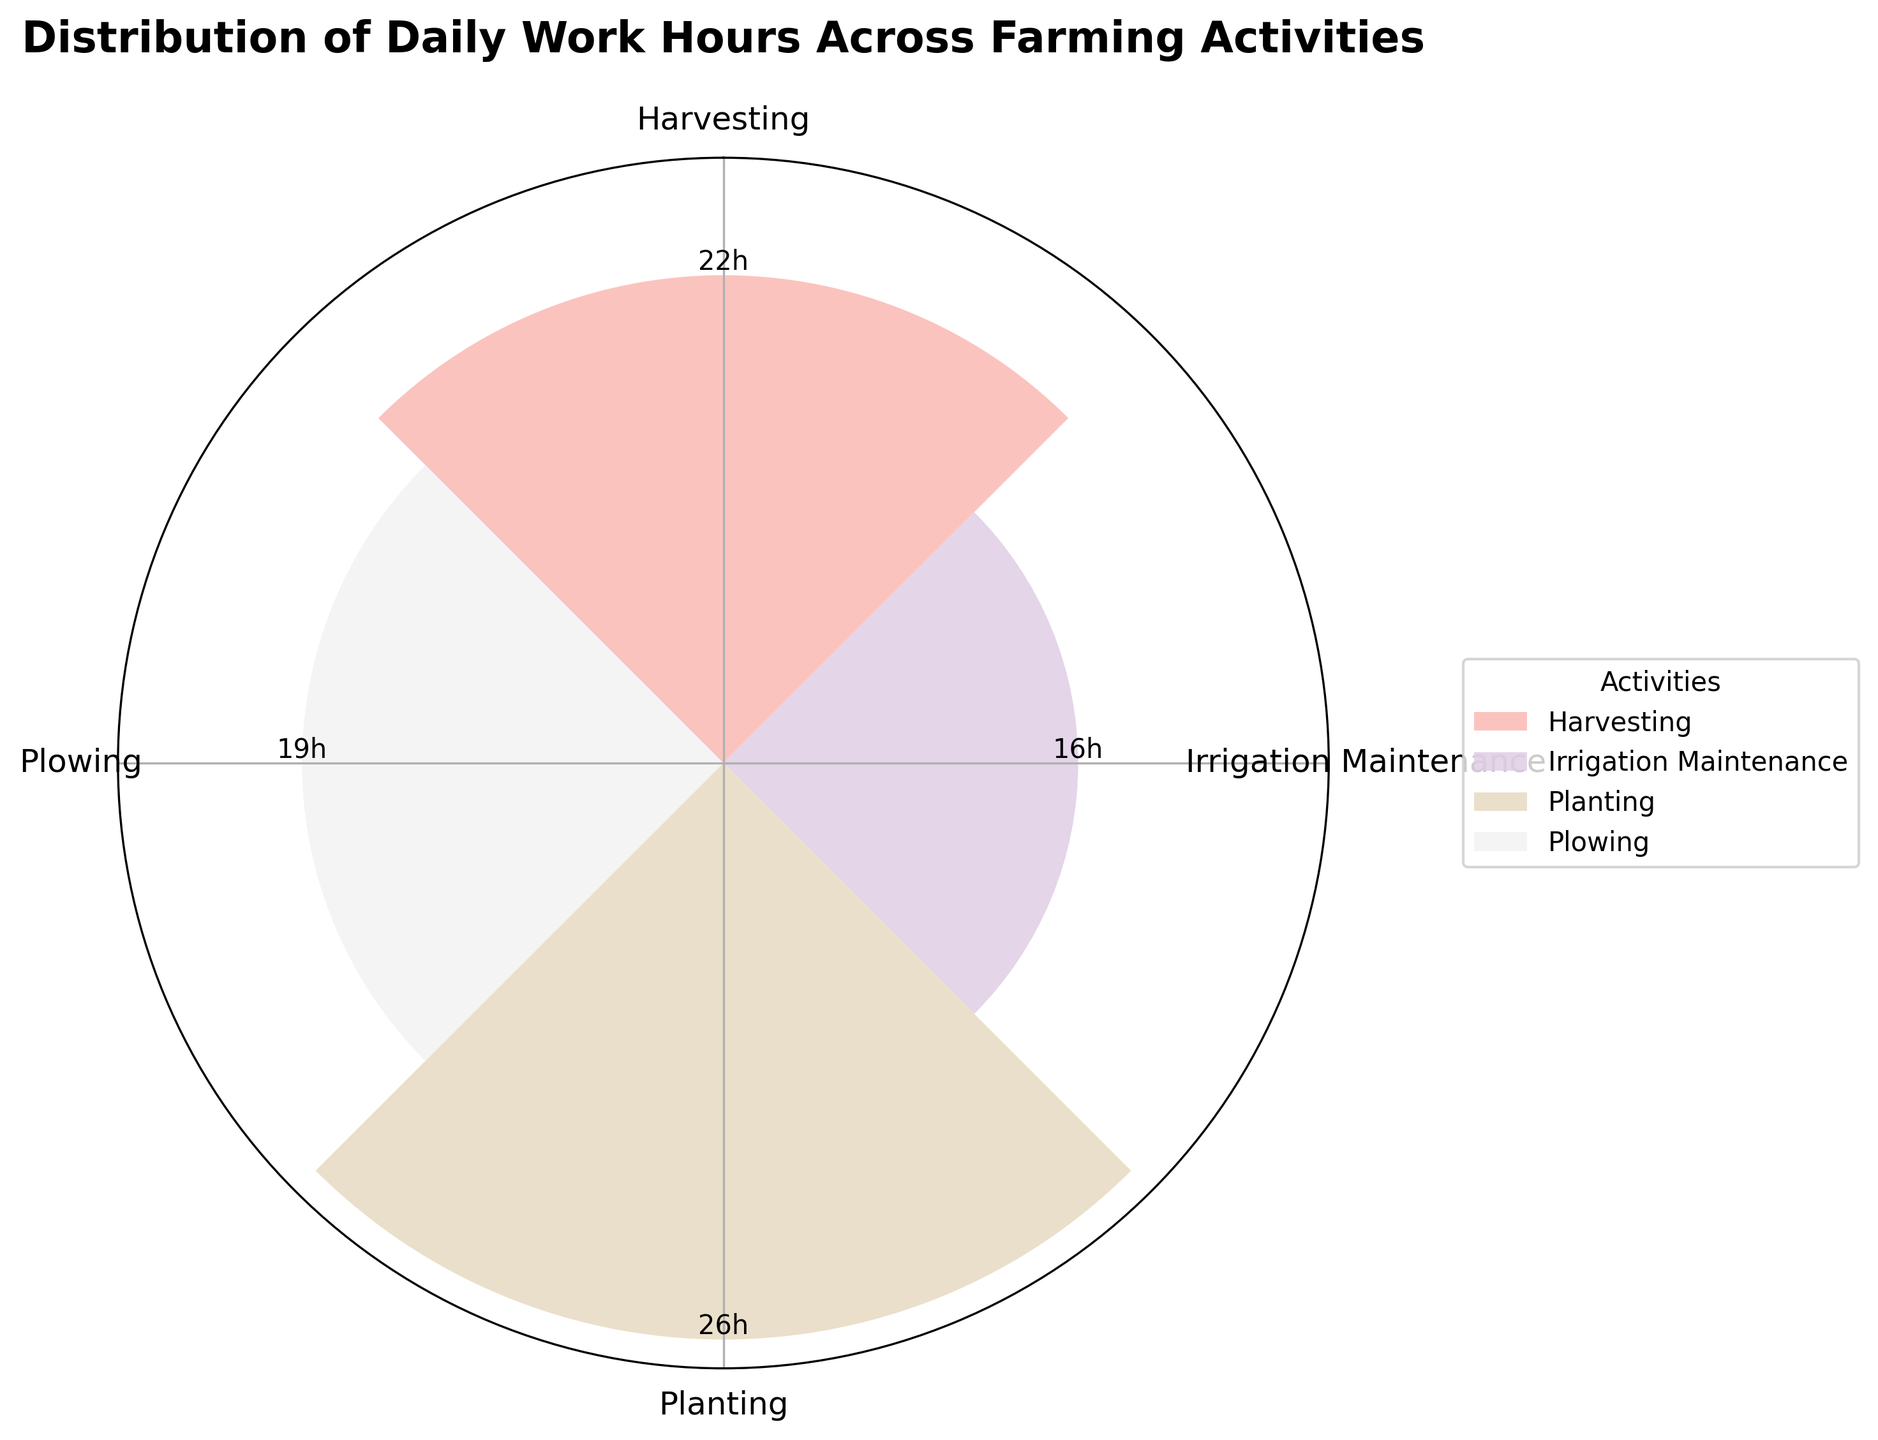What is the title of the figure? The title is written at the top of the figure.
Answer: Distribution of Daily Work Hours Across Farming Activities How many activities are represented in the chart? The number of distinct bars corresponds to the number of activities.
Answer: 4 Which activity has the highest total hours spent? By comparing the heights of each bar, the tallest bar indicates the activity with the highest total hours.
Answer: Planting What is the sum of hours spent on Plowing and Harvesting? Add the heights of the bars representing Plowing and Harvesting.
Answer: 19 Which activity has fewer total hours spent: Irrigation Maintenance or Harvesting? Compare the heights of the bars for Irrigation Maintenance and Harvesting.
Answer: Irrigation Maintenance Is any activity performed for exactly 20 hours? Check if any bar reaches the 20-hour mark.
Answer: No Which activities have more than 15 hours spent? Identify the bars taller than the 15-hour mark.
Answer: Plowing, Planting, Harvesting How does the total time spent on Planting compare to Plowing? Compare the heights of the bars for Planting and Plowing to determine if one is greater, less, or equal to the other.
Answer: Planting is greater What is the average number of hours spent per activity? Sum the heights of all bars and divide by the number of activities.
Answer: 20 If the activity with the least hours was doubled, would it become the highest? Double the height of the bar representing the least hours and compare it to the heights of other bars.
Answer: No 